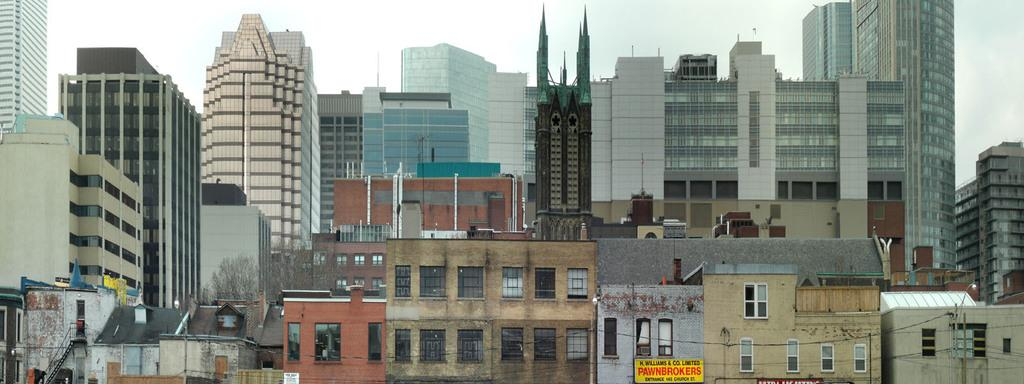Provide a one-sentence caption for the provided image. H Williams & Co Pawnbrokers sign in a cityscape. 